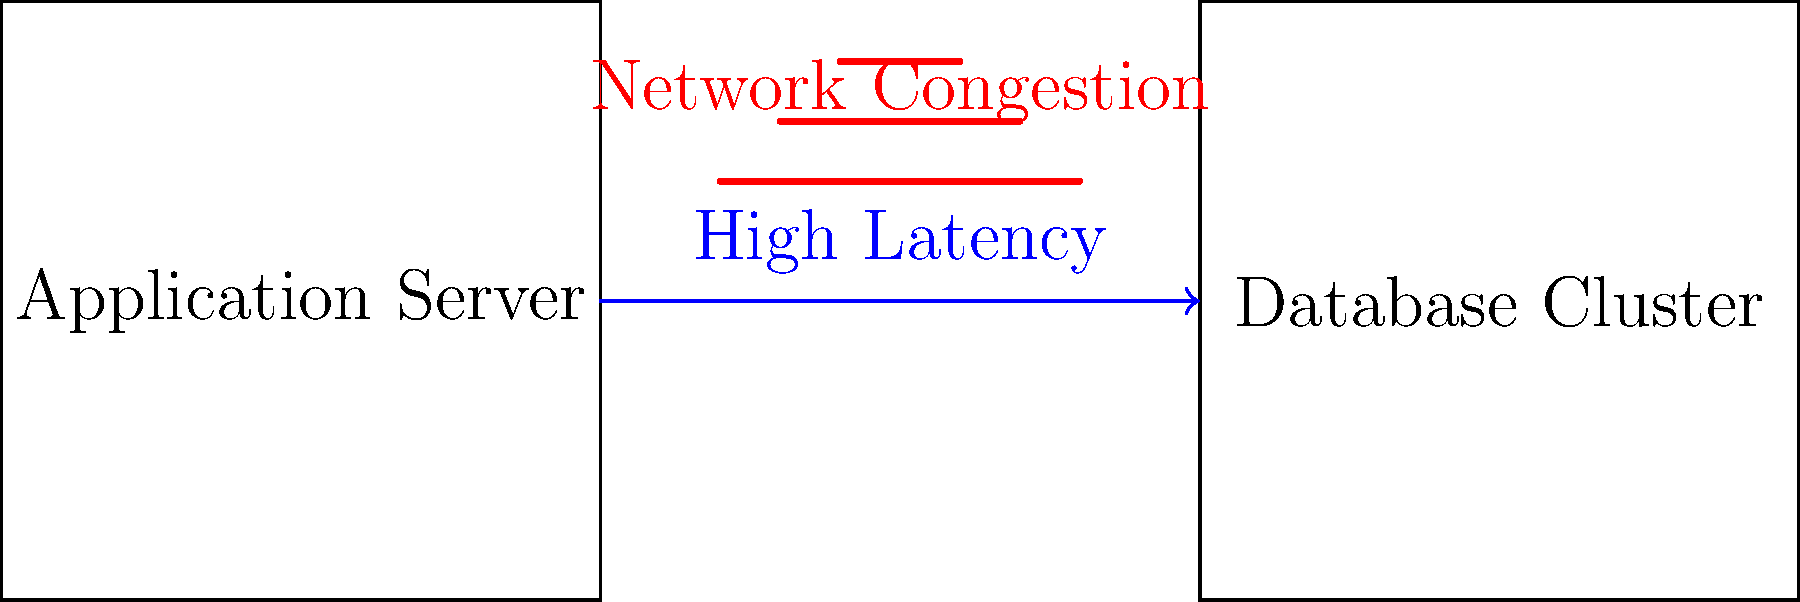In the network diagram shown, there is high latency between the application server and the database cluster. What is the most likely cause of this issue, and what should be the first step in troubleshooting this problem? To troubleshoot this network latency issue, we should follow these steps:

1. Identify the problem: The diagram shows high latency between the application server and database cluster, with network congestion indicated.

2. Analyze the symptoms: High latency and network congestion suggest that the network path between the two components is experiencing heavy traffic or bottlenecks.

3. Consider possible causes:
   a) Insufficient bandwidth
   b) Network device misconfiguration
   c) Faulty hardware
   d) Excessive network traffic

4. Determine the first troubleshooting step: In this case, the most appropriate first step would be to measure and analyze the network traffic between the application server and database cluster.

5. Justify the choice: By analyzing network traffic, we can:
   - Confirm the existence and severity of congestion
   - Identify any unusual patterns or unexpected data flows
   - Determine if the issue is consistent or intermittent
   - Gather data to support further troubleshooting steps

6. Subsequent steps: Based on the traffic analysis results, we can then proceed with more specific troubleshooting actions, such as:
   - Upgrading network capacity if bandwidth is insufficient
   - Optimizing network device configurations
   - Investigating and resolving any hardware issues
   - Implementing traffic shaping or Quality of Service (QoS) policies

By starting with network traffic analysis, we ensure that we have a clear understanding of the problem before taking any potentially disruptive actions.
Answer: Analyze network traffic between application server and database cluster 